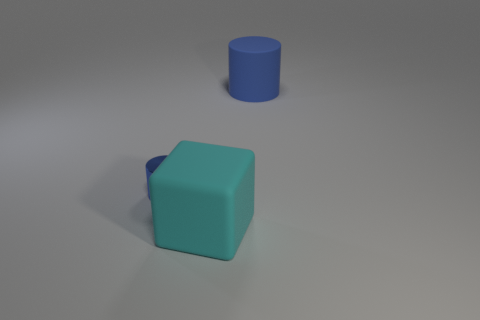Is there any other thing that is made of the same material as the small blue cylinder?
Your answer should be very brief. No. The metal object that is the same shape as the blue rubber object is what size?
Ensure brevity in your answer.  Small. There is a object that is both behind the big cyan rubber block and right of the blue shiny cylinder; what material is it?
Offer a terse response. Rubber. There is a large rubber thing to the left of the matte cylinder; is it the same color as the small thing?
Give a very brief answer. No. Is the color of the tiny thing the same as the big rubber object that is on the right side of the cyan rubber cube?
Offer a very short reply. Yes. There is a cyan thing; are there any blue metallic objects in front of it?
Ensure brevity in your answer.  No. Do the big blue cylinder and the big block have the same material?
Provide a succinct answer. Yes. There is a cyan cube that is the same size as the blue matte cylinder; what material is it?
Ensure brevity in your answer.  Rubber. How many objects are either cyan cubes that are on the left side of the big blue thing or blue rubber objects?
Ensure brevity in your answer.  2. Is the number of big blue rubber cylinders that are in front of the tiny metal cylinder the same as the number of big cyan cubes?
Ensure brevity in your answer.  No. 